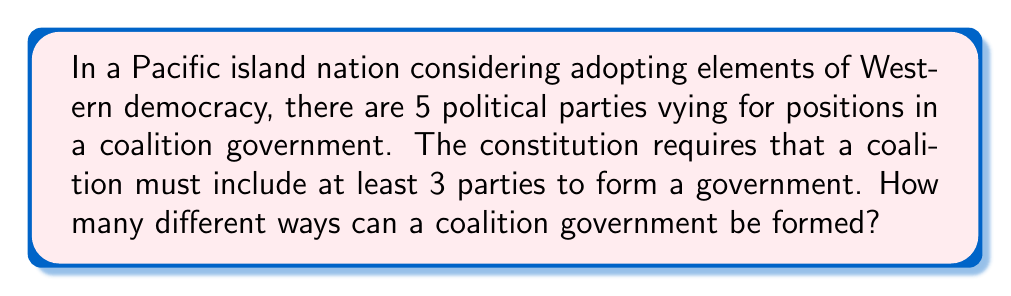Solve this math problem. Let's approach this step-by-step:

1) We need to find the total number of ways to select 3, 4, or 5 parties from the 5 available parties.

2) This is a combination problem. We'll use the combination formula:

   $${n \choose r} = \frac{n!}{r!(n-r)!}$$

   where $n$ is the total number of parties and $r$ is the number of parties in the coalition.

3) For a coalition of 3 parties:
   $${5 \choose 3} = \frac{5!}{3!(5-3)!} = \frac{5!}{3!2!} = 10$$

4) For a coalition of 4 parties:
   $${5 \choose 4} = \frac{5!}{4!(5-4)!} = \frac{5!}{4!1!} = 5$$

5) For a coalition of all 5 parties:
   $${5 \choose 5} = \frac{5!}{5!(5-5)!} = \frac{5!}{5!0!} = 1$$

6) The total number of possible coalitions is the sum of these:

   $$10 + 5 + 1 = 16$$

Therefore, there are 16 different ways to form a coalition government.
Answer: 16 ways 